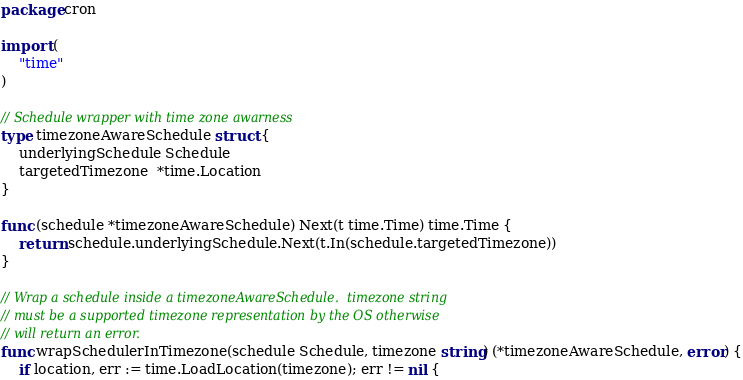Convert code to text. <code><loc_0><loc_0><loc_500><loc_500><_Go_>package cron

import (
	"time"
)

// Schedule wrapper with time zone awarness
type timezoneAwareSchedule struct {
	underlyingSchedule Schedule
	targetedTimezone  *time.Location
}

func (schedule *timezoneAwareSchedule) Next(t time.Time) time.Time {
	return schedule.underlyingSchedule.Next(t.In(schedule.targetedTimezone))
}

// Wrap a schedule inside a timezoneAwareSchedule.  timezone string
// must be a supported timezone representation by the OS otherwise
// will return an error.
func wrapSchedulerInTimezone(schedule Schedule, timezone string) (*timezoneAwareSchedule, error) {
	if location, err := time.LoadLocation(timezone); err != nil {</code> 